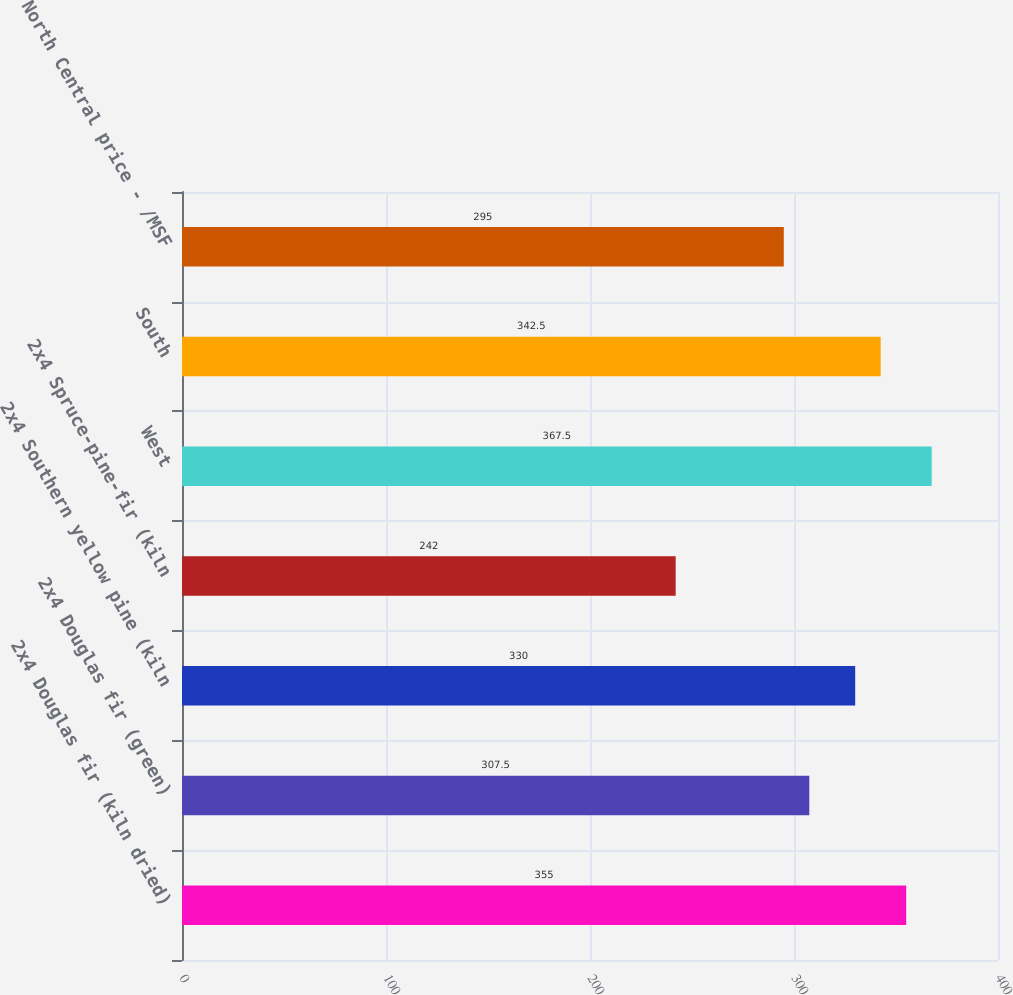Convert chart to OTSL. <chart><loc_0><loc_0><loc_500><loc_500><bar_chart><fcel>2x4 Douglas fir (kiln dried)<fcel>2x4 Douglas fir (green)<fcel>2x4 Southern yellow pine (kiln<fcel>2x4 Spruce-pine-fir (kiln<fcel>West<fcel>South<fcel>North Central price - /MSF<nl><fcel>355<fcel>307.5<fcel>330<fcel>242<fcel>367.5<fcel>342.5<fcel>295<nl></chart> 